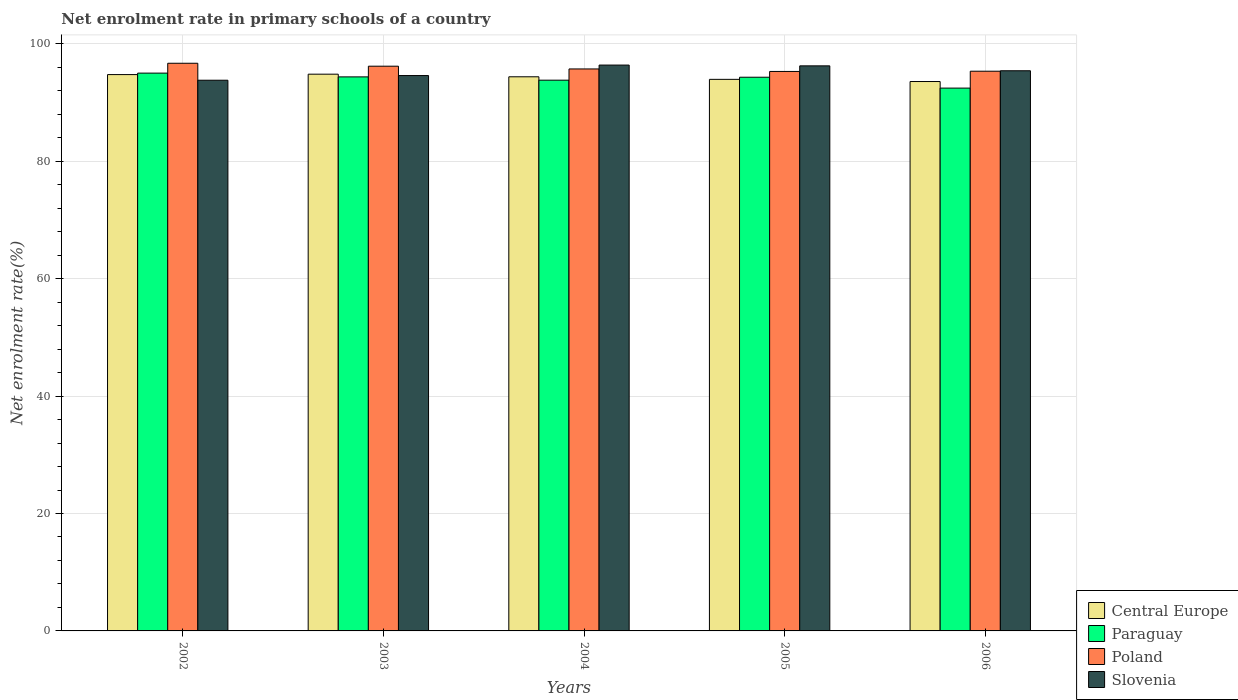Are the number of bars per tick equal to the number of legend labels?
Your response must be concise. Yes. How many bars are there on the 3rd tick from the right?
Ensure brevity in your answer.  4. What is the label of the 1st group of bars from the left?
Ensure brevity in your answer.  2002. What is the net enrolment rate in primary schools in Slovenia in 2003?
Your answer should be very brief. 94.59. Across all years, what is the maximum net enrolment rate in primary schools in Slovenia?
Your answer should be compact. 96.38. Across all years, what is the minimum net enrolment rate in primary schools in Poland?
Your response must be concise. 95.29. In which year was the net enrolment rate in primary schools in Poland maximum?
Keep it short and to the point. 2002. What is the total net enrolment rate in primary schools in Slovenia in the graph?
Offer a very short reply. 476.4. What is the difference between the net enrolment rate in primary schools in Poland in 2004 and that in 2005?
Your answer should be very brief. 0.42. What is the difference between the net enrolment rate in primary schools in Paraguay in 2003 and the net enrolment rate in primary schools in Slovenia in 2002?
Offer a terse response. 0.57. What is the average net enrolment rate in primary schools in Paraguay per year?
Give a very brief answer. 93.99. In the year 2005, what is the difference between the net enrolment rate in primary schools in Slovenia and net enrolment rate in primary schools in Paraguay?
Offer a terse response. 1.94. In how many years, is the net enrolment rate in primary schools in Central Europe greater than 96 %?
Make the answer very short. 0. What is the ratio of the net enrolment rate in primary schools in Slovenia in 2002 to that in 2006?
Offer a very short reply. 0.98. Is the net enrolment rate in primary schools in Paraguay in 2004 less than that in 2005?
Provide a succinct answer. Yes. Is the difference between the net enrolment rate in primary schools in Slovenia in 2002 and 2005 greater than the difference between the net enrolment rate in primary schools in Paraguay in 2002 and 2005?
Your answer should be very brief. No. What is the difference between the highest and the second highest net enrolment rate in primary schools in Central Europe?
Give a very brief answer. 0.07. What is the difference between the highest and the lowest net enrolment rate in primary schools in Poland?
Provide a short and direct response. 1.39. In how many years, is the net enrolment rate in primary schools in Paraguay greater than the average net enrolment rate in primary schools in Paraguay taken over all years?
Your response must be concise. 3. Is it the case that in every year, the sum of the net enrolment rate in primary schools in Poland and net enrolment rate in primary schools in Paraguay is greater than the sum of net enrolment rate in primary schools in Slovenia and net enrolment rate in primary schools in Central Europe?
Offer a very short reply. No. What does the 4th bar from the left in 2002 represents?
Keep it short and to the point. Slovenia. What does the 3rd bar from the right in 2004 represents?
Ensure brevity in your answer.  Paraguay. Is it the case that in every year, the sum of the net enrolment rate in primary schools in Central Europe and net enrolment rate in primary schools in Slovenia is greater than the net enrolment rate in primary schools in Poland?
Make the answer very short. Yes. How many bars are there?
Your answer should be compact. 20. Are all the bars in the graph horizontal?
Ensure brevity in your answer.  No. How many years are there in the graph?
Ensure brevity in your answer.  5. Are the values on the major ticks of Y-axis written in scientific E-notation?
Provide a short and direct response. No. How many legend labels are there?
Make the answer very short. 4. What is the title of the graph?
Your response must be concise. Net enrolment rate in primary schools of a country. Does "Slovenia" appear as one of the legend labels in the graph?
Offer a terse response. Yes. What is the label or title of the X-axis?
Ensure brevity in your answer.  Years. What is the label or title of the Y-axis?
Your response must be concise. Net enrolment rate(%). What is the Net enrolment rate(%) in Central Europe in 2002?
Your answer should be very brief. 94.75. What is the Net enrolment rate(%) in Paraguay in 2002?
Ensure brevity in your answer.  95.01. What is the Net enrolment rate(%) in Poland in 2002?
Offer a very short reply. 96.68. What is the Net enrolment rate(%) of Slovenia in 2002?
Your answer should be compact. 93.79. What is the Net enrolment rate(%) in Central Europe in 2003?
Give a very brief answer. 94.82. What is the Net enrolment rate(%) of Paraguay in 2003?
Make the answer very short. 94.36. What is the Net enrolment rate(%) of Poland in 2003?
Offer a terse response. 96.18. What is the Net enrolment rate(%) of Slovenia in 2003?
Provide a short and direct response. 94.59. What is the Net enrolment rate(%) of Central Europe in 2004?
Your answer should be compact. 94.38. What is the Net enrolment rate(%) in Paraguay in 2004?
Offer a terse response. 93.8. What is the Net enrolment rate(%) in Poland in 2004?
Ensure brevity in your answer.  95.71. What is the Net enrolment rate(%) of Slovenia in 2004?
Make the answer very short. 96.38. What is the Net enrolment rate(%) in Central Europe in 2005?
Your answer should be very brief. 93.94. What is the Net enrolment rate(%) in Paraguay in 2005?
Provide a succinct answer. 94.3. What is the Net enrolment rate(%) in Poland in 2005?
Provide a succinct answer. 95.29. What is the Net enrolment rate(%) of Slovenia in 2005?
Ensure brevity in your answer.  96.24. What is the Net enrolment rate(%) in Central Europe in 2006?
Offer a very short reply. 93.57. What is the Net enrolment rate(%) of Paraguay in 2006?
Your answer should be very brief. 92.45. What is the Net enrolment rate(%) in Poland in 2006?
Offer a terse response. 95.33. What is the Net enrolment rate(%) in Slovenia in 2006?
Your answer should be very brief. 95.41. Across all years, what is the maximum Net enrolment rate(%) in Central Europe?
Keep it short and to the point. 94.82. Across all years, what is the maximum Net enrolment rate(%) in Paraguay?
Offer a very short reply. 95.01. Across all years, what is the maximum Net enrolment rate(%) of Poland?
Offer a very short reply. 96.68. Across all years, what is the maximum Net enrolment rate(%) of Slovenia?
Your response must be concise. 96.38. Across all years, what is the minimum Net enrolment rate(%) of Central Europe?
Your answer should be compact. 93.57. Across all years, what is the minimum Net enrolment rate(%) in Paraguay?
Ensure brevity in your answer.  92.45. Across all years, what is the minimum Net enrolment rate(%) of Poland?
Ensure brevity in your answer.  95.29. Across all years, what is the minimum Net enrolment rate(%) in Slovenia?
Give a very brief answer. 93.79. What is the total Net enrolment rate(%) in Central Europe in the graph?
Give a very brief answer. 471.47. What is the total Net enrolment rate(%) in Paraguay in the graph?
Keep it short and to the point. 469.93. What is the total Net enrolment rate(%) in Poland in the graph?
Your response must be concise. 479.2. What is the total Net enrolment rate(%) of Slovenia in the graph?
Offer a very short reply. 476.4. What is the difference between the Net enrolment rate(%) in Central Europe in 2002 and that in 2003?
Give a very brief answer. -0.07. What is the difference between the Net enrolment rate(%) in Paraguay in 2002 and that in 2003?
Your answer should be very brief. 0.64. What is the difference between the Net enrolment rate(%) of Slovenia in 2002 and that in 2003?
Ensure brevity in your answer.  -0.8. What is the difference between the Net enrolment rate(%) of Central Europe in 2002 and that in 2004?
Offer a very short reply. 0.37. What is the difference between the Net enrolment rate(%) in Paraguay in 2002 and that in 2004?
Offer a terse response. 1.2. What is the difference between the Net enrolment rate(%) of Poland in 2002 and that in 2004?
Provide a succinct answer. 0.97. What is the difference between the Net enrolment rate(%) in Slovenia in 2002 and that in 2004?
Make the answer very short. -2.58. What is the difference between the Net enrolment rate(%) in Central Europe in 2002 and that in 2005?
Your answer should be very brief. 0.81. What is the difference between the Net enrolment rate(%) in Paraguay in 2002 and that in 2005?
Your response must be concise. 0.7. What is the difference between the Net enrolment rate(%) in Poland in 2002 and that in 2005?
Give a very brief answer. 1.39. What is the difference between the Net enrolment rate(%) of Slovenia in 2002 and that in 2005?
Provide a succinct answer. -2.45. What is the difference between the Net enrolment rate(%) of Central Europe in 2002 and that in 2006?
Your answer should be compact. 1.18. What is the difference between the Net enrolment rate(%) in Paraguay in 2002 and that in 2006?
Offer a terse response. 2.55. What is the difference between the Net enrolment rate(%) in Poland in 2002 and that in 2006?
Your response must be concise. 1.35. What is the difference between the Net enrolment rate(%) in Slovenia in 2002 and that in 2006?
Provide a short and direct response. -1.61. What is the difference between the Net enrolment rate(%) in Central Europe in 2003 and that in 2004?
Offer a terse response. 0.44. What is the difference between the Net enrolment rate(%) of Paraguay in 2003 and that in 2004?
Provide a short and direct response. 0.56. What is the difference between the Net enrolment rate(%) in Poland in 2003 and that in 2004?
Provide a short and direct response. 0.47. What is the difference between the Net enrolment rate(%) of Slovenia in 2003 and that in 2004?
Your answer should be compact. -1.79. What is the difference between the Net enrolment rate(%) of Central Europe in 2003 and that in 2005?
Provide a succinct answer. 0.88. What is the difference between the Net enrolment rate(%) in Paraguay in 2003 and that in 2005?
Give a very brief answer. 0.06. What is the difference between the Net enrolment rate(%) in Poland in 2003 and that in 2005?
Ensure brevity in your answer.  0.89. What is the difference between the Net enrolment rate(%) in Slovenia in 2003 and that in 2005?
Your response must be concise. -1.65. What is the difference between the Net enrolment rate(%) of Central Europe in 2003 and that in 2006?
Your answer should be compact. 1.25. What is the difference between the Net enrolment rate(%) in Paraguay in 2003 and that in 2006?
Provide a short and direct response. 1.91. What is the difference between the Net enrolment rate(%) in Poland in 2003 and that in 2006?
Your answer should be very brief. 0.85. What is the difference between the Net enrolment rate(%) in Slovenia in 2003 and that in 2006?
Make the answer very short. -0.82. What is the difference between the Net enrolment rate(%) in Central Europe in 2004 and that in 2005?
Your answer should be very brief. 0.44. What is the difference between the Net enrolment rate(%) of Paraguay in 2004 and that in 2005?
Provide a short and direct response. -0.5. What is the difference between the Net enrolment rate(%) of Poland in 2004 and that in 2005?
Give a very brief answer. 0.42. What is the difference between the Net enrolment rate(%) in Slovenia in 2004 and that in 2005?
Offer a very short reply. 0.13. What is the difference between the Net enrolment rate(%) of Central Europe in 2004 and that in 2006?
Keep it short and to the point. 0.81. What is the difference between the Net enrolment rate(%) in Paraguay in 2004 and that in 2006?
Provide a short and direct response. 1.35. What is the difference between the Net enrolment rate(%) in Poland in 2004 and that in 2006?
Your answer should be very brief. 0.38. What is the difference between the Net enrolment rate(%) of Slovenia in 2004 and that in 2006?
Your answer should be very brief. 0.97. What is the difference between the Net enrolment rate(%) of Central Europe in 2005 and that in 2006?
Ensure brevity in your answer.  0.37. What is the difference between the Net enrolment rate(%) of Paraguay in 2005 and that in 2006?
Make the answer very short. 1.85. What is the difference between the Net enrolment rate(%) of Poland in 2005 and that in 2006?
Your answer should be compact. -0.04. What is the difference between the Net enrolment rate(%) of Slovenia in 2005 and that in 2006?
Your answer should be compact. 0.83. What is the difference between the Net enrolment rate(%) in Central Europe in 2002 and the Net enrolment rate(%) in Paraguay in 2003?
Provide a succinct answer. 0.39. What is the difference between the Net enrolment rate(%) of Central Europe in 2002 and the Net enrolment rate(%) of Poland in 2003?
Provide a short and direct response. -1.43. What is the difference between the Net enrolment rate(%) in Central Europe in 2002 and the Net enrolment rate(%) in Slovenia in 2003?
Make the answer very short. 0.17. What is the difference between the Net enrolment rate(%) of Paraguay in 2002 and the Net enrolment rate(%) of Poland in 2003?
Your response must be concise. -1.18. What is the difference between the Net enrolment rate(%) in Paraguay in 2002 and the Net enrolment rate(%) in Slovenia in 2003?
Give a very brief answer. 0.42. What is the difference between the Net enrolment rate(%) of Poland in 2002 and the Net enrolment rate(%) of Slovenia in 2003?
Provide a succinct answer. 2.09. What is the difference between the Net enrolment rate(%) of Central Europe in 2002 and the Net enrolment rate(%) of Paraguay in 2004?
Ensure brevity in your answer.  0.95. What is the difference between the Net enrolment rate(%) in Central Europe in 2002 and the Net enrolment rate(%) in Poland in 2004?
Offer a terse response. -0.96. What is the difference between the Net enrolment rate(%) of Central Europe in 2002 and the Net enrolment rate(%) of Slovenia in 2004?
Your response must be concise. -1.62. What is the difference between the Net enrolment rate(%) of Paraguay in 2002 and the Net enrolment rate(%) of Poland in 2004?
Ensure brevity in your answer.  -0.71. What is the difference between the Net enrolment rate(%) of Paraguay in 2002 and the Net enrolment rate(%) of Slovenia in 2004?
Provide a succinct answer. -1.37. What is the difference between the Net enrolment rate(%) of Poland in 2002 and the Net enrolment rate(%) of Slovenia in 2004?
Offer a very short reply. 0.31. What is the difference between the Net enrolment rate(%) of Central Europe in 2002 and the Net enrolment rate(%) of Paraguay in 2005?
Your answer should be very brief. 0.45. What is the difference between the Net enrolment rate(%) in Central Europe in 2002 and the Net enrolment rate(%) in Poland in 2005?
Keep it short and to the point. -0.53. What is the difference between the Net enrolment rate(%) of Central Europe in 2002 and the Net enrolment rate(%) of Slovenia in 2005?
Provide a succinct answer. -1.49. What is the difference between the Net enrolment rate(%) of Paraguay in 2002 and the Net enrolment rate(%) of Poland in 2005?
Offer a very short reply. -0.28. What is the difference between the Net enrolment rate(%) in Paraguay in 2002 and the Net enrolment rate(%) in Slovenia in 2005?
Keep it short and to the point. -1.24. What is the difference between the Net enrolment rate(%) of Poland in 2002 and the Net enrolment rate(%) of Slovenia in 2005?
Your answer should be compact. 0.44. What is the difference between the Net enrolment rate(%) of Central Europe in 2002 and the Net enrolment rate(%) of Paraguay in 2006?
Give a very brief answer. 2.3. What is the difference between the Net enrolment rate(%) of Central Europe in 2002 and the Net enrolment rate(%) of Poland in 2006?
Make the answer very short. -0.58. What is the difference between the Net enrolment rate(%) of Central Europe in 2002 and the Net enrolment rate(%) of Slovenia in 2006?
Give a very brief answer. -0.65. What is the difference between the Net enrolment rate(%) in Paraguay in 2002 and the Net enrolment rate(%) in Poland in 2006?
Your response must be concise. -0.32. What is the difference between the Net enrolment rate(%) of Paraguay in 2002 and the Net enrolment rate(%) of Slovenia in 2006?
Your answer should be compact. -0.4. What is the difference between the Net enrolment rate(%) of Poland in 2002 and the Net enrolment rate(%) of Slovenia in 2006?
Give a very brief answer. 1.28. What is the difference between the Net enrolment rate(%) of Central Europe in 2003 and the Net enrolment rate(%) of Paraguay in 2004?
Provide a succinct answer. 1.02. What is the difference between the Net enrolment rate(%) of Central Europe in 2003 and the Net enrolment rate(%) of Poland in 2004?
Your response must be concise. -0.89. What is the difference between the Net enrolment rate(%) of Central Europe in 2003 and the Net enrolment rate(%) of Slovenia in 2004?
Give a very brief answer. -1.55. What is the difference between the Net enrolment rate(%) in Paraguay in 2003 and the Net enrolment rate(%) in Poland in 2004?
Provide a succinct answer. -1.35. What is the difference between the Net enrolment rate(%) of Paraguay in 2003 and the Net enrolment rate(%) of Slovenia in 2004?
Provide a succinct answer. -2.01. What is the difference between the Net enrolment rate(%) of Poland in 2003 and the Net enrolment rate(%) of Slovenia in 2004?
Give a very brief answer. -0.19. What is the difference between the Net enrolment rate(%) of Central Europe in 2003 and the Net enrolment rate(%) of Paraguay in 2005?
Offer a terse response. 0.52. What is the difference between the Net enrolment rate(%) of Central Europe in 2003 and the Net enrolment rate(%) of Poland in 2005?
Give a very brief answer. -0.47. What is the difference between the Net enrolment rate(%) in Central Europe in 2003 and the Net enrolment rate(%) in Slovenia in 2005?
Offer a very short reply. -1.42. What is the difference between the Net enrolment rate(%) in Paraguay in 2003 and the Net enrolment rate(%) in Poland in 2005?
Provide a succinct answer. -0.93. What is the difference between the Net enrolment rate(%) in Paraguay in 2003 and the Net enrolment rate(%) in Slovenia in 2005?
Keep it short and to the point. -1.88. What is the difference between the Net enrolment rate(%) in Poland in 2003 and the Net enrolment rate(%) in Slovenia in 2005?
Give a very brief answer. -0.06. What is the difference between the Net enrolment rate(%) of Central Europe in 2003 and the Net enrolment rate(%) of Paraguay in 2006?
Provide a succinct answer. 2.37. What is the difference between the Net enrolment rate(%) in Central Europe in 2003 and the Net enrolment rate(%) in Poland in 2006?
Provide a succinct answer. -0.51. What is the difference between the Net enrolment rate(%) in Central Europe in 2003 and the Net enrolment rate(%) in Slovenia in 2006?
Provide a short and direct response. -0.58. What is the difference between the Net enrolment rate(%) of Paraguay in 2003 and the Net enrolment rate(%) of Poland in 2006?
Offer a terse response. -0.97. What is the difference between the Net enrolment rate(%) in Paraguay in 2003 and the Net enrolment rate(%) in Slovenia in 2006?
Your answer should be compact. -1.04. What is the difference between the Net enrolment rate(%) in Poland in 2003 and the Net enrolment rate(%) in Slovenia in 2006?
Give a very brief answer. 0.78. What is the difference between the Net enrolment rate(%) in Central Europe in 2004 and the Net enrolment rate(%) in Paraguay in 2005?
Your response must be concise. 0.08. What is the difference between the Net enrolment rate(%) of Central Europe in 2004 and the Net enrolment rate(%) of Poland in 2005?
Provide a short and direct response. -0.91. What is the difference between the Net enrolment rate(%) in Central Europe in 2004 and the Net enrolment rate(%) in Slovenia in 2005?
Your response must be concise. -1.86. What is the difference between the Net enrolment rate(%) in Paraguay in 2004 and the Net enrolment rate(%) in Poland in 2005?
Your response must be concise. -1.49. What is the difference between the Net enrolment rate(%) in Paraguay in 2004 and the Net enrolment rate(%) in Slovenia in 2005?
Ensure brevity in your answer.  -2.44. What is the difference between the Net enrolment rate(%) of Poland in 2004 and the Net enrolment rate(%) of Slovenia in 2005?
Ensure brevity in your answer.  -0.53. What is the difference between the Net enrolment rate(%) of Central Europe in 2004 and the Net enrolment rate(%) of Paraguay in 2006?
Offer a terse response. 1.93. What is the difference between the Net enrolment rate(%) in Central Europe in 2004 and the Net enrolment rate(%) in Poland in 2006?
Ensure brevity in your answer.  -0.95. What is the difference between the Net enrolment rate(%) in Central Europe in 2004 and the Net enrolment rate(%) in Slovenia in 2006?
Ensure brevity in your answer.  -1.03. What is the difference between the Net enrolment rate(%) in Paraguay in 2004 and the Net enrolment rate(%) in Poland in 2006?
Provide a short and direct response. -1.53. What is the difference between the Net enrolment rate(%) in Paraguay in 2004 and the Net enrolment rate(%) in Slovenia in 2006?
Give a very brief answer. -1.6. What is the difference between the Net enrolment rate(%) in Poland in 2004 and the Net enrolment rate(%) in Slovenia in 2006?
Offer a very short reply. 0.31. What is the difference between the Net enrolment rate(%) of Central Europe in 2005 and the Net enrolment rate(%) of Paraguay in 2006?
Keep it short and to the point. 1.49. What is the difference between the Net enrolment rate(%) in Central Europe in 2005 and the Net enrolment rate(%) in Poland in 2006?
Provide a short and direct response. -1.39. What is the difference between the Net enrolment rate(%) in Central Europe in 2005 and the Net enrolment rate(%) in Slovenia in 2006?
Offer a very short reply. -1.46. What is the difference between the Net enrolment rate(%) in Paraguay in 2005 and the Net enrolment rate(%) in Poland in 2006?
Make the answer very short. -1.03. What is the difference between the Net enrolment rate(%) in Paraguay in 2005 and the Net enrolment rate(%) in Slovenia in 2006?
Ensure brevity in your answer.  -1.1. What is the difference between the Net enrolment rate(%) of Poland in 2005 and the Net enrolment rate(%) of Slovenia in 2006?
Your answer should be compact. -0.12. What is the average Net enrolment rate(%) in Central Europe per year?
Keep it short and to the point. 94.29. What is the average Net enrolment rate(%) in Paraguay per year?
Provide a short and direct response. 93.99. What is the average Net enrolment rate(%) in Poland per year?
Ensure brevity in your answer.  95.84. What is the average Net enrolment rate(%) of Slovenia per year?
Your answer should be very brief. 95.28. In the year 2002, what is the difference between the Net enrolment rate(%) of Central Europe and Net enrolment rate(%) of Paraguay?
Offer a very short reply. -0.25. In the year 2002, what is the difference between the Net enrolment rate(%) in Central Europe and Net enrolment rate(%) in Poland?
Provide a succinct answer. -1.93. In the year 2002, what is the difference between the Net enrolment rate(%) of Central Europe and Net enrolment rate(%) of Slovenia?
Ensure brevity in your answer.  0.96. In the year 2002, what is the difference between the Net enrolment rate(%) of Paraguay and Net enrolment rate(%) of Poland?
Provide a short and direct response. -1.68. In the year 2002, what is the difference between the Net enrolment rate(%) of Paraguay and Net enrolment rate(%) of Slovenia?
Your answer should be very brief. 1.21. In the year 2002, what is the difference between the Net enrolment rate(%) in Poland and Net enrolment rate(%) in Slovenia?
Give a very brief answer. 2.89. In the year 2003, what is the difference between the Net enrolment rate(%) in Central Europe and Net enrolment rate(%) in Paraguay?
Offer a very short reply. 0.46. In the year 2003, what is the difference between the Net enrolment rate(%) in Central Europe and Net enrolment rate(%) in Poland?
Your answer should be compact. -1.36. In the year 2003, what is the difference between the Net enrolment rate(%) in Central Europe and Net enrolment rate(%) in Slovenia?
Provide a short and direct response. 0.23. In the year 2003, what is the difference between the Net enrolment rate(%) in Paraguay and Net enrolment rate(%) in Poland?
Ensure brevity in your answer.  -1.82. In the year 2003, what is the difference between the Net enrolment rate(%) of Paraguay and Net enrolment rate(%) of Slovenia?
Offer a very short reply. -0.23. In the year 2003, what is the difference between the Net enrolment rate(%) in Poland and Net enrolment rate(%) in Slovenia?
Your answer should be compact. 1.59. In the year 2004, what is the difference between the Net enrolment rate(%) of Central Europe and Net enrolment rate(%) of Paraguay?
Give a very brief answer. 0.58. In the year 2004, what is the difference between the Net enrolment rate(%) of Central Europe and Net enrolment rate(%) of Poland?
Your answer should be very brief. -1.33. In the year 2004, what is the difference between the Net enrolment rate(%) of Central Europe and Net enrolment rate(%) of Slovenia?
Offer a terse response. -2. In the year 2004, what is the difference between the Net enrolment rate(%) in Paraguay and Net enrolment rate(%) in Poland?
Provide a short and direct response. -1.91. In the year 2004, what is the difference between the Net enrolment rate(%) in Paraguay and Net enrolment rate(%) in Slovenia?
Provide a short and direct response. -2.57. In the year 2004, what is the difference between the Net enrolment rate(%) of Poland and Net enrolment rate(%) of Slovenia?
Your answer should be very brief. -0.66. In the year 2005, what is the difference between the Net enrolment rate(%) in Central Europe and Net enrolment rate(%) in Paraguay?
Your response must be concise. -0.36. In the year 2005, what is the difference between the Net enrolment rate(%) in Central Europe and Net enrolment rate(%) in Poland?
Your response must be concise. -1.35. In the year 2005, what is the difference between the Net enrolment rate(%) in Central Europe and Net enrolment rate(%) in Slovenia?
Give a very brief answer. -2.3. In the year 2005, what is the difference between the Net enrolment rate(%) in Paraguay and Net enrolment rate(%) in Poland?
Provide a succinct answer. -0.99. In the year 2005, what is the difference between the Net enrolment rate(%) in Paraguay and Net enrolment rate(%) in Slovenia?
Provide a short and direct response. -1.94. In the year 2005, what is the difference between the Net enrolment rate(%) in Poland and Net enrolment rate(%) in Slovenia?
Ensure brevity in your answer.  -0.95. In the year 2006, what is the difference between the Net enrolment rate(%) in Central Europe and Net enrolment rate(%) in Paraguay?
Keep it short and to the point. 1.12. In the year 2006, what is the difference between the Net enrolment rate(%) in Central Europe and Net enrolment rate(%) in Poland?
Offer a terse response. -1.76. In the year 2006, what is the difference between the Net enrolment rate(%) of Central Europe and Net enrolment rate(%) of Slovenia?
Offer a terse response. -1.83. In the year 2006, what is the difference between the Net enrolment rate(%) in Paraguay and Net enrolment rate(%) in Poland?
Offer a terse response. -2.88. In the year 2006, what is the difference between the Net enrolment rate(%) of Paraguay and Net enrolment rate(%) of Slovenia?
Offer a very short reply. -2.95. In the year 2006, what is the difference between the Net enrolment rate(%) of Poland and Net enrolment rate(%) of Slovenia?
Provide a short and direct response. -0.08. What is the ratio of the Net enrolment rate(%) of Central Europe in 2002 to that in 2003?
Give a very brief answer. 1. What is the ratio of the Net enrolment rate(%) of Paraguay in 2002 to that in 2003?
Offer a very short reply. 1.01. What is the ratio of the Net enrolment rate(%) in Poland in 2002 to that in 2003?
Provide a short and direct response. 1.01. What is the ratio of the Net enrolment rate(%) in Slovenia in 2002 to that in 2003?
Provide a short and direct response. 0.99. What is the ratio of the Net enrolment rate(%) in Paraguay in 2002 to that in 2004?
Keep it short and to the point. 1.01. What is the ratio of the Net enrolment rate(%) of Slovenia in 2002 to that in 2004?
Your response must be concise. 0.97. What is the ratio of the Net enrolment rate(%) in Central Europe in 2002 to that in 2005?
Make the answer very short. 1.01. What is the ratio of the Net enrolment rate(%) of Paraguay in 2002 to that in 2005?
Your response must be concise. 1.01. What is the ratio of the Net enrolment rate(%) of Poland in 2002 to that in 2005?
Make the answer very short. 1.01. What is the ratio of the Net enrolment rate(%) of Slovenia in 2002 to that in 2005?
Ensure brevity in your answer.  0.97. What is the ratio of the Net enrolment rate(%) of Central Europe in 2002 to that in 2006?
Your answer should be compact. 1.01. What is the ratio of the Net enrolment rate(%) in Paraguay in 2002 to that in 2006?
Make the answer very short. 1.03. What is the ratio of the Net enrolment rate(%) in Poland in 2002 to that in 2006?
Give a very brief answer. 1.01. What is the ratio of the Net enrolment rate(%) of Slovenia in 2002 to that in 2006?
Keep it short and to the point. 0.98. What is the ratio of the Net enrolment rate(%) in Central Europe in 2003 to that in 2004?
Offer a terse response. 1. What is the ratio of the Net enrolment rate(%) in Paraguay in 2003 to that in 2004?
Keep it short and to the point. 1.01. What is the ratio of the Net enrolment rate(%) of Slovenia in 2003 to that in 2004?
Your answer should be very brief. 0.98. What is the ratio of the Net enrolment rate(%) in Central Europe in 2003 to that in 2005?
Provide a succinct answer. 1.01. What is the ratio of the Net enrolment rate(%) of Paraguay in 2003 to that in 2005?
Ensure brevity in your answer.  1. What is the ratio of the Net enrolment rate(%) of Poland in 2003 to that in 2005?
Your answer should be very brief. 1.01. What is the ratio of the Net enrolment rate(%) in Slovenia in 2003 to that in 2005?
Offer a terse response. 0.98. What is the ratio of the Net enrolment rate(%) of Central Europe in 2003 to that in 2006?
Provide a succinct answer. 1.01. What is the ratio of the Net enrolment rate(%) of Paraguay in 2003 to that in 2006?
Provide a succinct answer. 1.02. What is the ratio of the Net enrolment rate(%) in Poland in 2003 to that in 2006?
Your answer should be very brief. 1.01. What is the ratio of the Net enrolment rate(%) of Central Europe in 2004 to that in 2006?
Your response must be concise. 1.01. What is the ratio of the Net enrolment rate(%) of Paraguay in 2004 to that in 2006?
Offer a very short reply. 1.01. What is the ratio of the Net enrolment rate(%) in Slovenia in 2004 to that in 2006?
Provide a succinct answer. 1.01. What is the ratio of the Net enrolment rate(%) in Poland in 2005 to that in 2006?
Provide a succinct answer. 1. What is the ratio of the Net enrolment rate(%) in Slovenia in 2005 to that in 2006?
Ensure brevity in your answer.  1.01. What is the difference between the highest and the second highest Net enrolment rate(%) of Central Europe?
Make the answer very short. 0.07. What is the difference between the highest and the second highest Net enrolment rate(%) of Paraguay?
Provide a succinct answer. 0.64. What is the difference between the highest and the second highest Net enrolment rate(%) in Poland?
Keep it short and to the point. 0.5. What is the difference between the highest and the second highest Net enrolment rate(%) of Slovenia?
Your answer should be very brief. 0.13. What is the difference between the highest and the lowest Net enrolment rate(%) of Central Europe?
Ensure brevity in your answer.  1.25. What is the difference between the highest and the lowest Net enrolment rate(%) in Paraguay?
Your response must be concise. 2.55. What is the difference between the highest and the lowest Net enrolment rate(%) in Poland?
Offer a very short reply. 1.39. What is the difference between the highest and the lowest Net enrolment rate(%) in Slovenia?
Keep it short and to the point. 2.58. 